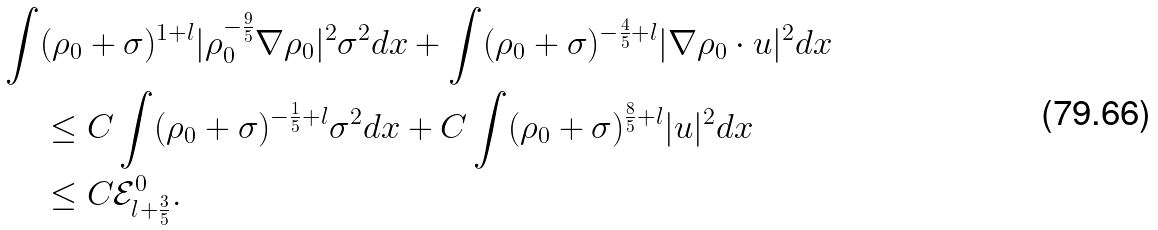Convert formula to latex. <formula><loc_0><loc_0><loc_500><loc_500>\int & ( \rho _ { 0 } + \sigma ) ^ { 1 + l } | \rho _ { 0 } ^ { - \frac { 9 } { 5 } } \nabla \rho _ { 0 } | ^ { 2 } \sigma ^ { 2 } d x + \int ( \rho _ { 0 } + \sigma ) ^ { - \frac { 4 } { 5 } + l } | \nabla \rho _ { 0 } \cdot u | ^ { 2 } d x \\ & \leq C \int ( \rho _ { 0 } + \sigma ) ^ { - \frac { 1 } { 5 } + l } \sigma ^ { 2 } d x + C \int ( \rho _ { 0 } + \sigma ) ^ { \frac { 8 } { 5 } + l } | u | ^ { 2 } d x \\ & \leq C \mathcal { E } _ { l + \frac { 3 } { 5 } } ^ { 0 } .</formula> 